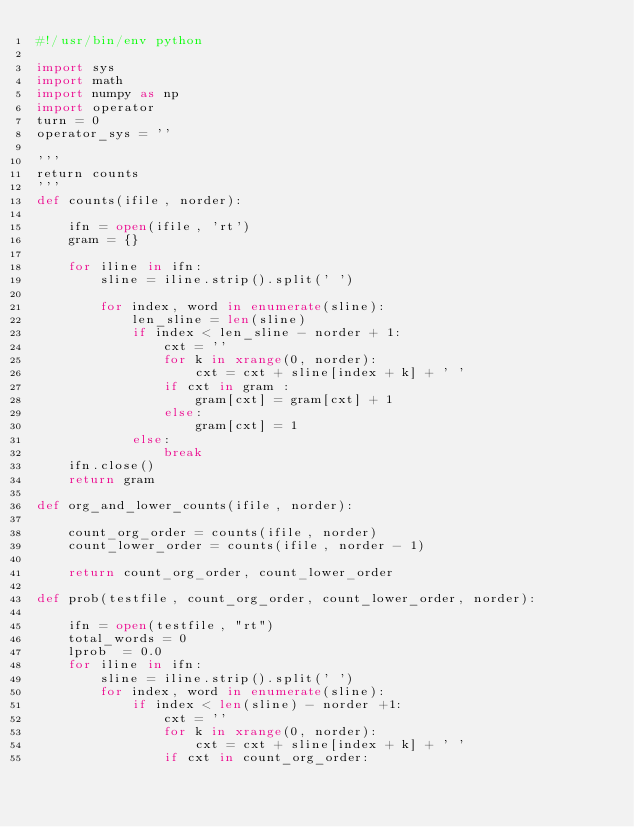<code> <loc_0><loc_0><loc_500><loc_500><_Python_>#!/usr/bin/env python

import sys
import math
import numpy as np
import operator
turn = 0
operator_sys = ''

'''
return counts
'''
def counts(ifile, norder):

    ifn = open(ifile, 'rt')
    gram = {}

    for iline in ifn:
        sline = iline.strip().split(' ')

        for index, word in enumerate(sline):
            len_sline = len(sline)
            if index < len_sline - norder + 1:
                cxt = ''
                for k in xrange(0, norder):
                    cxt = cxt + sline[index + k] + ' '
                if cxt in gram :
                    gram[cxt] = gram[cxt] + 1
                else:
                    gram[cxt] = 1
            else:
                break
    ifn.close()
    return gram

def org_and_lower_counts(ifile, norder):

    count_org_order = counts(ifile, norder)
    count_lower_order = counts(ifile, norder - 1)

    return count_org_order, count_lower_order

def prob(testfile, count_org_order, count_lower_order, norder):

    ifn = open(testfile, "rt")
    total_words = 0
    lprob  = 0.0
    for iline in ifn:
        sline = iline.strip().split(' ')
        for index, word in enumerate(sline):
            if index < len(sline) - norder +1:
                cxt = ''
                for k in xrange(0, norder):
                    cxt = cxt + sline[index + k] + ' '
                if cxt in count_org_order:</code> 